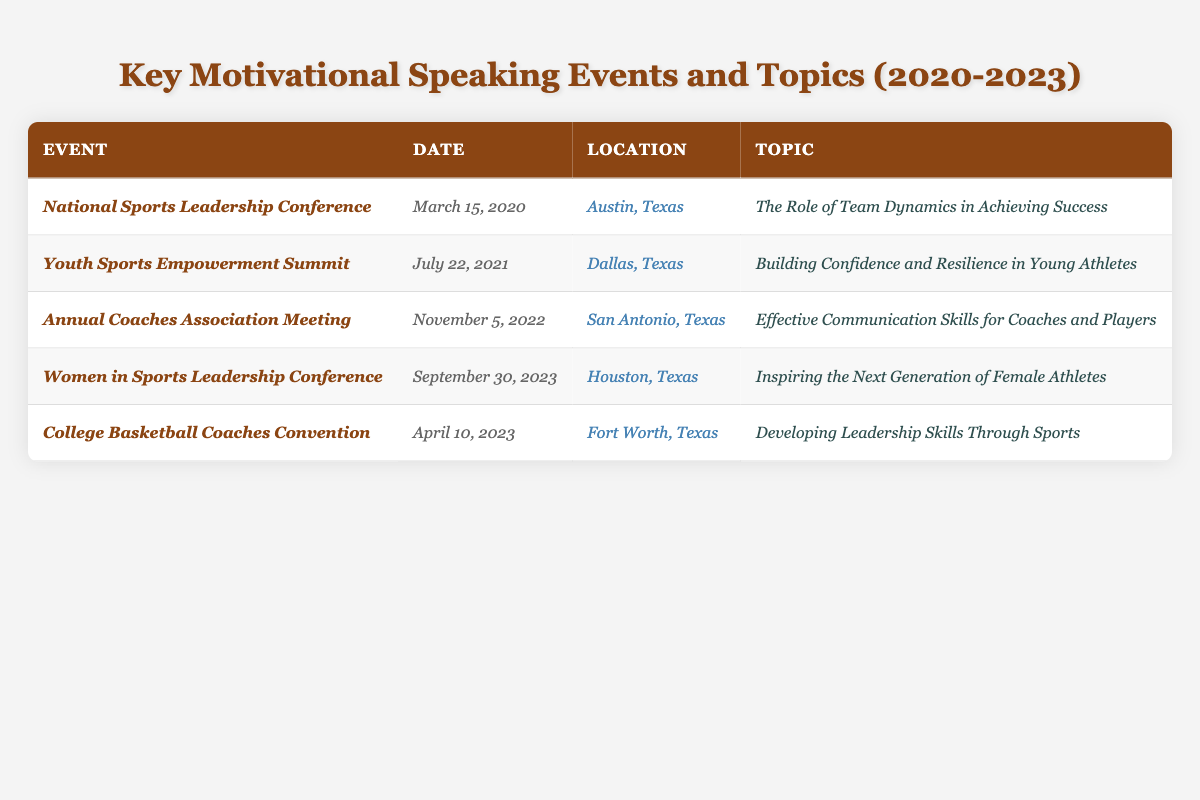What is the date of the Women in Sports Leadership Conference? The table lists the event along with its date, and the Women in Sports Leadership Conference is associated with September 30, 2023.
Answer: September 30, 2023 Where was the Youth Sports Empowerment Summit held? The location for the Youth Sports Empowerment Summit is provided in the table, which states it was in Dallas, Texas.
Answer: Dallas, Texas How many events took place in 2023? By examining the table, I can see there are two events listed for the year 2023: the Women in Sports Leadership Conference and the College Basketball Coaches Convention.
Answer: 2 What was the topic of the National Sports Leadership Conference? The table specifies that the topic covered during the National Sports Leadership Conference was "The Role of Team Dynamics in Achieving Success."
Answer: The Role of Team Dynamics in Achieving Success Did the Annual Coaches Association Meeting cover communication skills? Yes, the table indicates that the topic discussed was "Effective Communication Skills for Coaches and Players," confirming that communication skills were covered.
Answer: Yes Which event occurred first: the Youth Sports Empowerment Summit or the Annual Coaches Association Meeting? The Youth Sports Empowerment Summit occurred on July 22, 2021, and the Annual Coaches Association Meeting took place on November 5, 2022. Since July 2021 is before November 2022, the Youth Sports Empowerment Summit occurred first.
Answer: Youth Sports Empowerment Summit What is the common theme of the topics covered in the events listed? The table highlights a consistent focus on aspects of leadership, skills development, or empowerment related to sports, showing a theme of motivation and personal growth for athletes and coaches.
Answer: Leadership and empowerment in sports Which location hosted the most events according to the table? Observing the locations, Austin, Dallas, San Antonio, Houston, and Fort Worth each hosted one event, showing no single location hosted more than one event.
Answer: None; each hosted one event What was the last event listed in the table, and what topic did it cover? The last event in the table is the College Basketball Coaches Convention, which is scheduled for April 10, 2023, and covers "Developing Leadership Skills Through Sports."
Answer: College Basketball Coaches Convention, Developing Leadership Skills Through Sports How many of the listed events were specifically aimed at empowering either coaches or athletes? By analyzing the topics, both the Youth Sports Empowerment Summit (focused on young athletes) and the Annual Coaches Association Meeting (focused on coaches), indicate that there are two events aimed at empowerment.
Answer: 2 